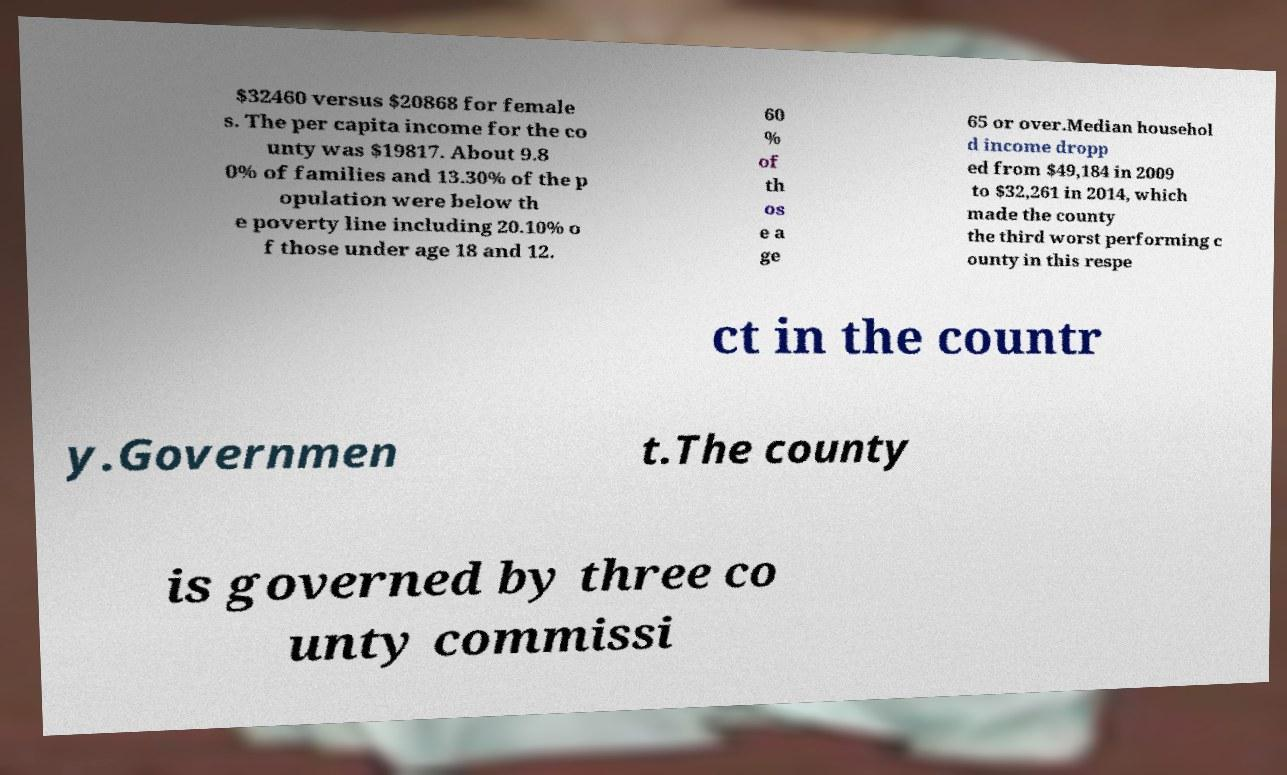Please read and relay the text visible in this image. What does it say? $32460 versus $20868 for female s. The per capita income for the co unty was $19817. About 9.8 0% of families and 13.30% of the p opulation were below th e poverty line including 20.10% o f those under age 18 and 12. 60 % of th os e a ge 65 or over.Median househol d income dropp ed from $49,184 in 2009 to $32,261 in 2014, which made the county the third worst performing c ounty in this respe ct in the countr y.Governmen t.The county is governed by three co unty commissi 